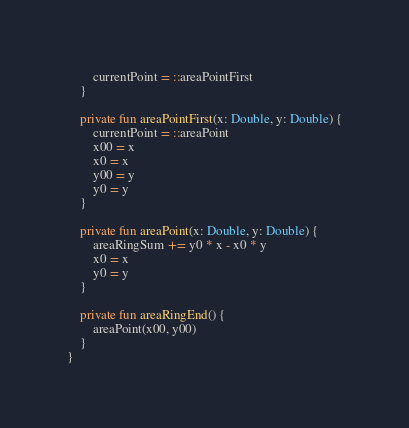Convert code to text. <code><loc_0><loc_0><loc_500><loc_500><_Kotlin_>        currentPoint = ::areaPointFirst
    }

    private fun areaPointFirst(x: Double, y: Double) {
        currentPoint = ::areaPoint
        x00 = x
        x0 = x
        y00 = y
        y0 = y
    }

    private fun areaPoint(x: Double, y: Double) {
        areaRingSum += y0 * x - x0 * y
        x0 = x
        y0 = y
    }

    private fun areaRingEnd() {
        areaPoint(x00, y00)
    }
}</code> 